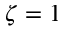<formula> <loc_0><loc_0><loc_500><loc_500>\zeta = 1</formula> 